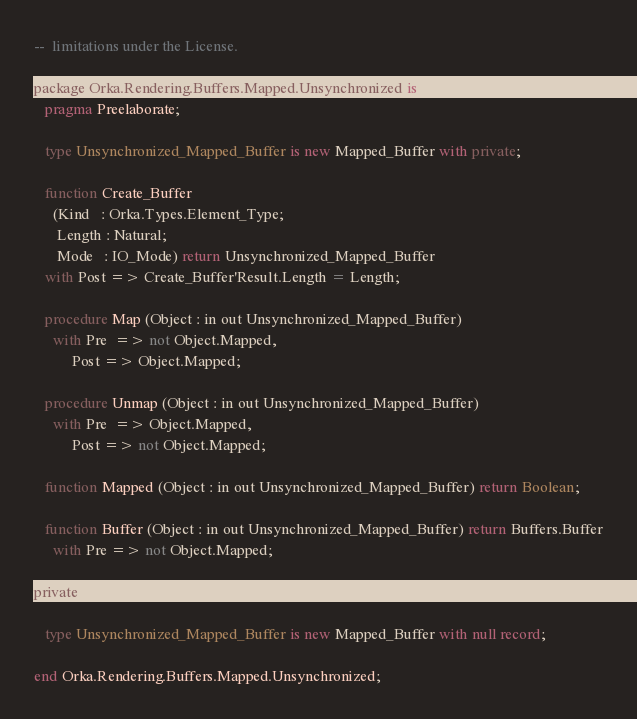<code> <loc_0><loc_0><loc_500><loc_500><_Ada_>--  limitations under the License.

package Orka.Rendering.Buffers.Mapped.Unsynchronized is
   pragma Preelaborate;

   type Unsynchronized_Mapped_Buffer is new Mapped_Buffer with private;

   function Create_Buffer
     (Kind   : Orka.Types.Element_Type;
      Length : Natural;
      Mode   : IO_Mode) return Unsynchronized_Mapped_Buffer
   with Post => Create_Buffer'Result.Length = Length;

   procedure Map (Object : in out Unsynchronized_Mapped_Buffer)
     with Pre  => not Object.Mapped,
          Post => Object.Mapped;

   procedure Unmap (Object : in out Unsynchronized_Mapped_Buffer)
     with Pre  => Object.Mapped,
          Post => not Object.Mapped;

   function Mapped (Object : in out Unsynchronized_Mapped_Buffer) return Boolean;

   function Buffer (Object : in out Unsynchronized_Mapped_Buffer) return Buffers.Buffer
     with Pre => not Object.Mapped;

private

   type Unsynchronized_Mapped_Buffer is new Mapped_Buffer with null record;

end Orka.Rendering.Buffers.Mapped.Unsynchronized;
</code> 